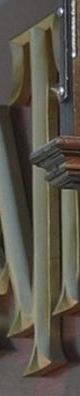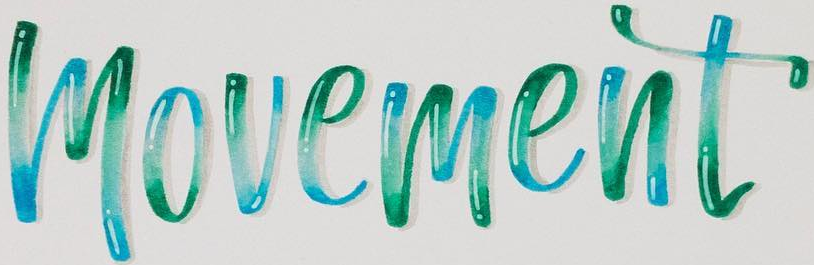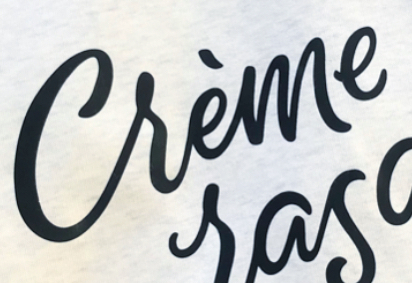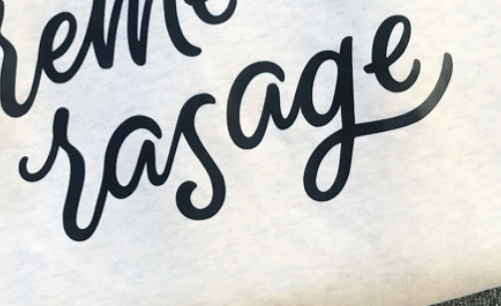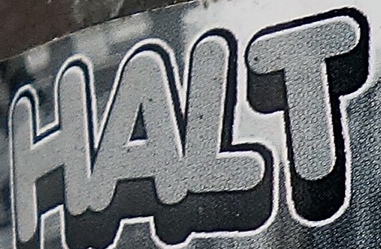What text appears in these images from left to right, separated by a semicolon? T; movement; Crème; rasage; HALT 